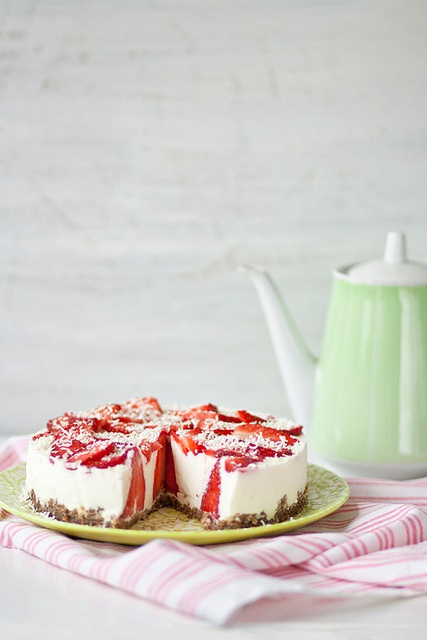Describe the objects in this image and their specific colors. I can see a cake in lightgray, white, lightpink, tan, and brown tones in this image. 